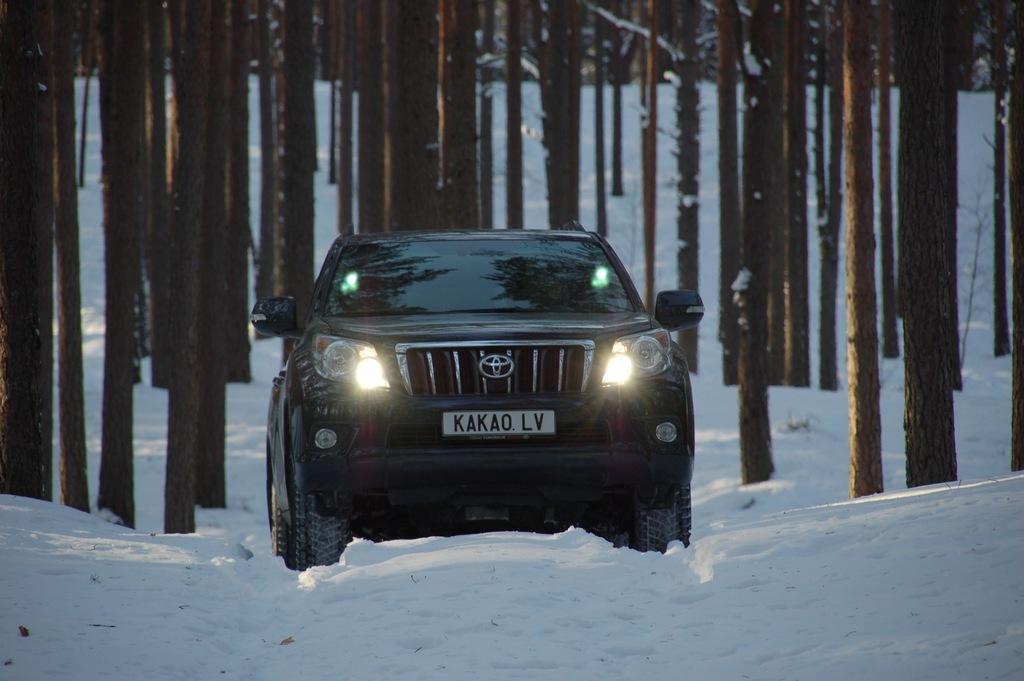In one or two sentences, can you explain what this image depicts? In the middle of the picture, we see a black car. At the bottom, we see the ice. In the background, we see the stems of the trees and these trees are covered with the ice. 